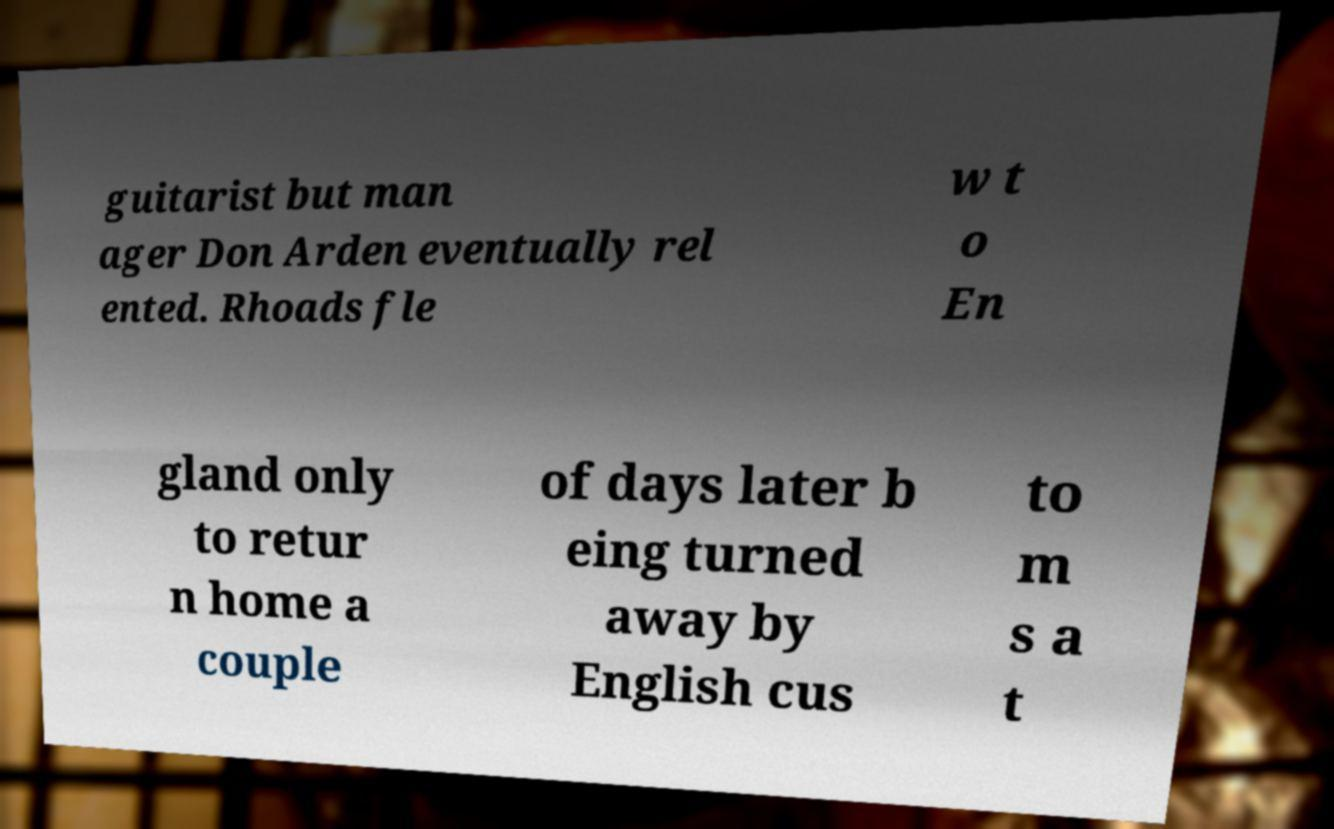There's text embedded in this image that I need extracted. Can you transcribe it verbatim? guitarist but man ager Don Arden eventually rel ented. Rhoads fle w t o En gland only to retur n home a couple of days later b eing turned away by English cus to m s a t 